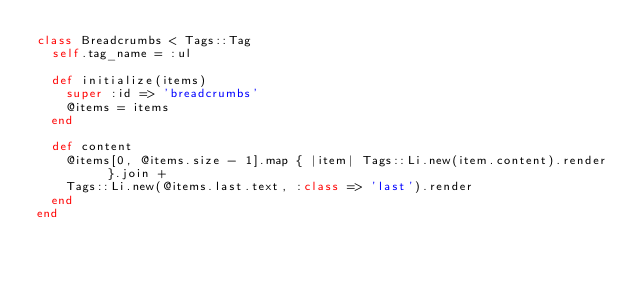<code> <loc_0><loc_0><loc_500><loc_500><_Ruby_>class Breadcrumbs < Tags::Tag
  self.tag_name = :ul
  
  def initialize(items)
    super :id => 'breadcrumbs'
    @items = items
  end

  def content
    @items[0, @items.size - 1].map { |item| Tags::Li.new(item.content).render }.join + 
    Tags::Li.new(@items.last.text, :class => 'last').render
  end
end</code> 